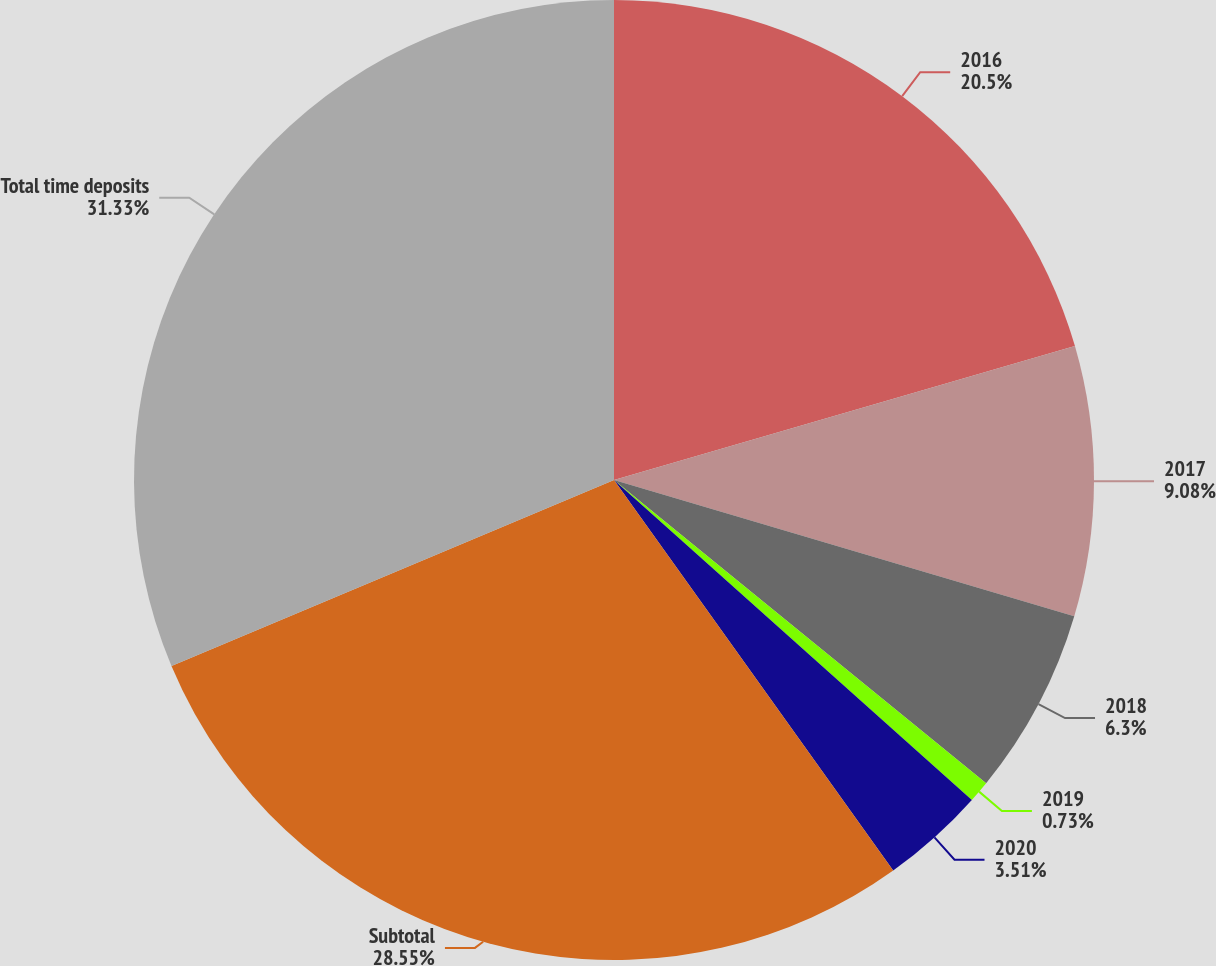Convert chart to OTSL. <chart><loc_0><loc_0><loc_500><loc_500><pie_chart><fcel>2016<fcel>2017<fcel>2018<fcel>2019<fcel>2020<fcel>Subtotal<fcel>Total time deposits<nl><fcel>20.5%<fcel>9.08%<fcel>6.3%<fcel>0.73%<fcel>3.51%<fcel>28.55%<fcel>31.33%<nl></chart> 